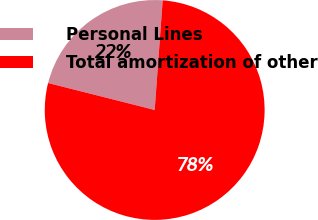Convert chart. <chart><loc_0><loc_0><loc_500><loc_500><pie_chart><fcel>Personal Lines<fcel>Total amortization of other<nl><fcel>22.22%<fcel>77.78%<nl></chart> 